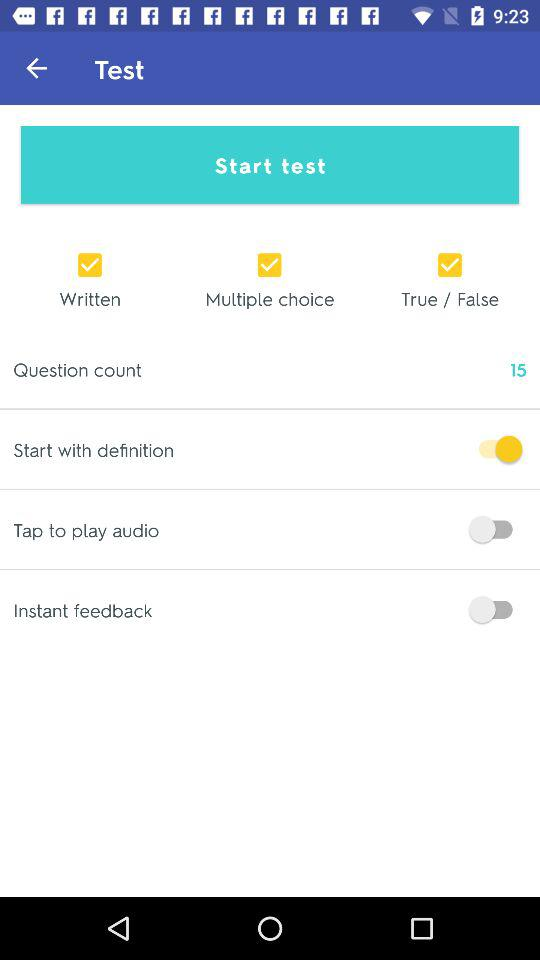What is the status of the "Start with definition"? The status is "on". 